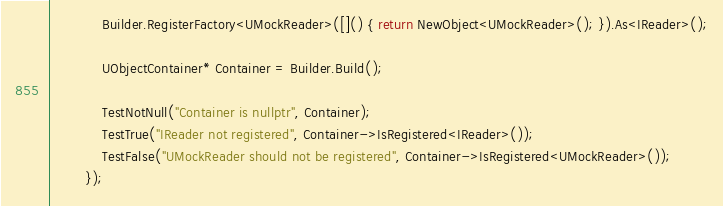Convert code to text. <code><loc_0><loc_0><loc_500><loc_500><_C++_>            Builder.RegisterFactory<UMockReader>([]() { return NewObject<UMockReader>(); }).As<IReader>();

            UObjectContainer* Container = Builder.Build();

            TestNotNull("Container is nullptr", Container);
            TestTrue("IReader not registered", Container->IsRegistered<IReader>());
            TestFalse("UMockReader should not be registered", Container->IsRegistered<UMockReader>());
        });
</code> 